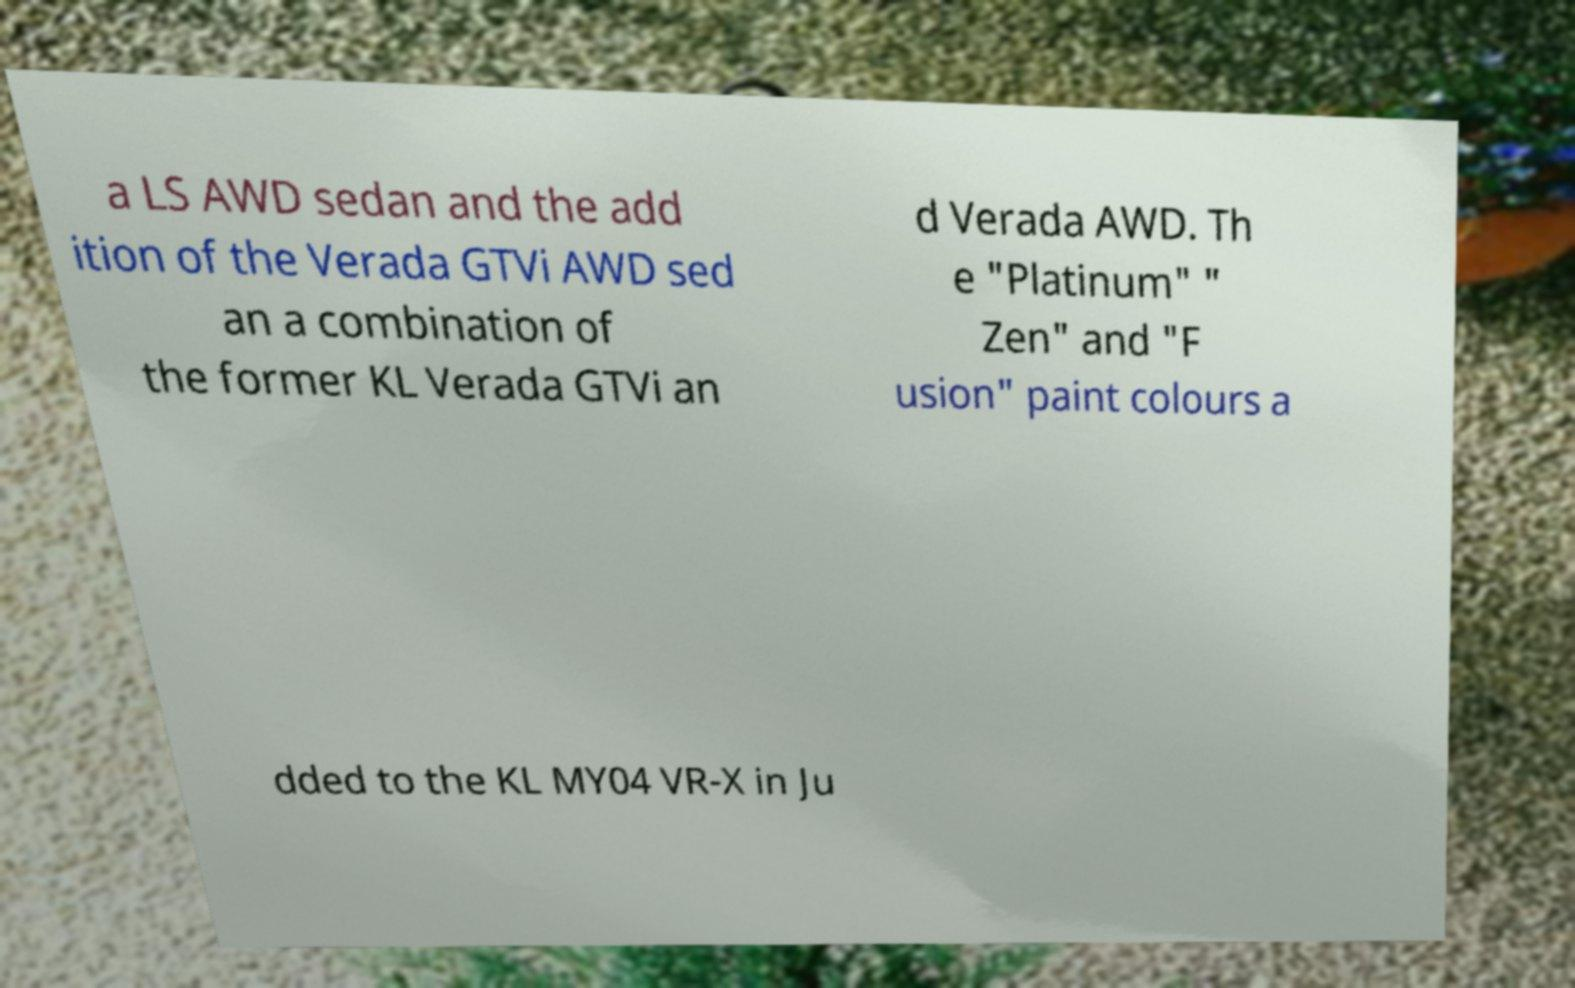What messages or text are displayed in this image? I need them in a readable, typed format. a LS AWD sedan and the add ition of the Verada GTVi AWD sed an a combination of the former KL Verada GTVi an d Verada AWD. Th e "Platinum" " Zen" and "F usion" paint colours a dded to the KL MY04 VR-X in Ju 